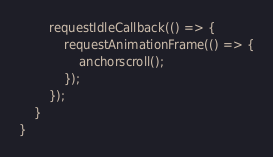<code> <loc_0><loc_0><loc_500><loc_500><_TypeScript_>        requestIdleCallback(() => {
            requestAnimationFrame(() => {
                anchorscroll();
            });
        });
    }
}
</code> 